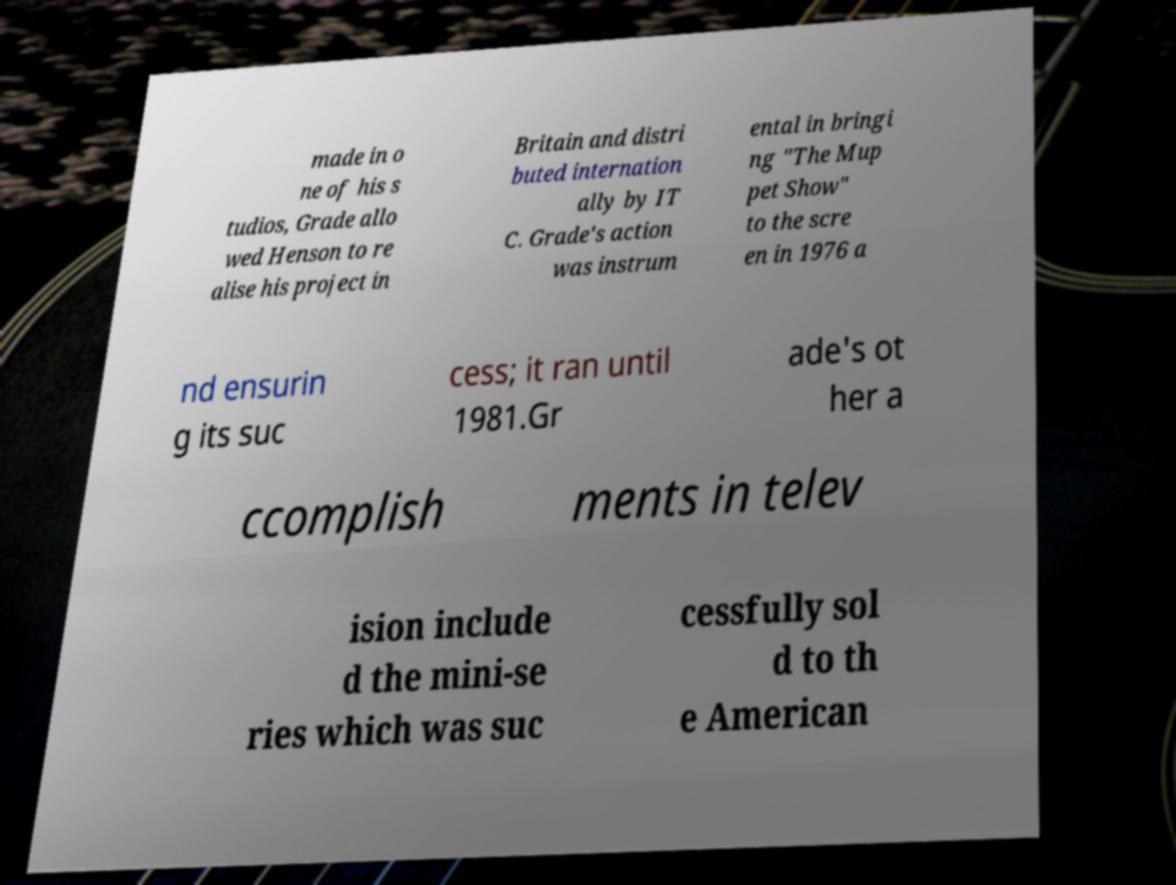There's text embedded in this image that I need extracted. Can you transcribe it verbatim? made in o ne of his s tudios, Grade allo wed Henson to re alise his project in Britain and distri buted internation ally by IT C. Grade's action was instrum ental in bringi ng "The Mup pet Show" to the scre en in 1976 a nd ensurin g its suc cess; it ran until 1981.Gr ade's ot her a ccomplish ments in telev ision include d the mini-se ries which was suc cessfully sol d to th e American 